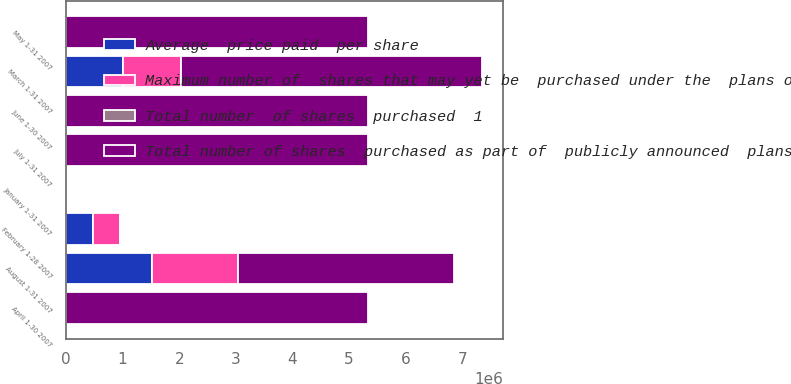Convert chart. <chart><loc_0><loc_0><loc_500><loc_500><stacked_bar_chart><ecel><fcel>January 1-31 2007<fcel>February 1-28 2007<fcel>March 1-31 2007<fcel>April 1-30 2007<fcel>May 1-31 2007<fcel>June 1-30 2007<fcel>July 1-31 2007<fcel>August 1-31 2007<nl><fcel>Maximum number of  shares that may yet be  purchased under the  plans or programs<fcel>0<fcel>478267<fcel>1.01281e+06<fcel>0<fcel>0<fcel>0<fcel>0<fcel>1.52215e+06<nl><fcel>Total number  of shares  purchased  1<fcel>0<fcel>43.82<fcel>42.64<fcel>0<fcel>0<fcel>0<fcel>0<fcel>41.42<nl><fcel>Average  price paid  per share<fcel>0<fcel>478267<fcel>1.01232e+06<fcel>0<fcel>0<fcel>0<fcel>0<fcel>1.52215e+06<nl><fcel>Total number of shares  purchased as part of  publicly announced  plans or programs<fcel>20.71<fcel>20.71<fcel>5.32866e+06<fcel>5.32866e+06<fcel>5.32866e+06<fcel>5.32866e+06<fcel>5.32866e+06<fcel>3.80652e+06<nl></chart> 